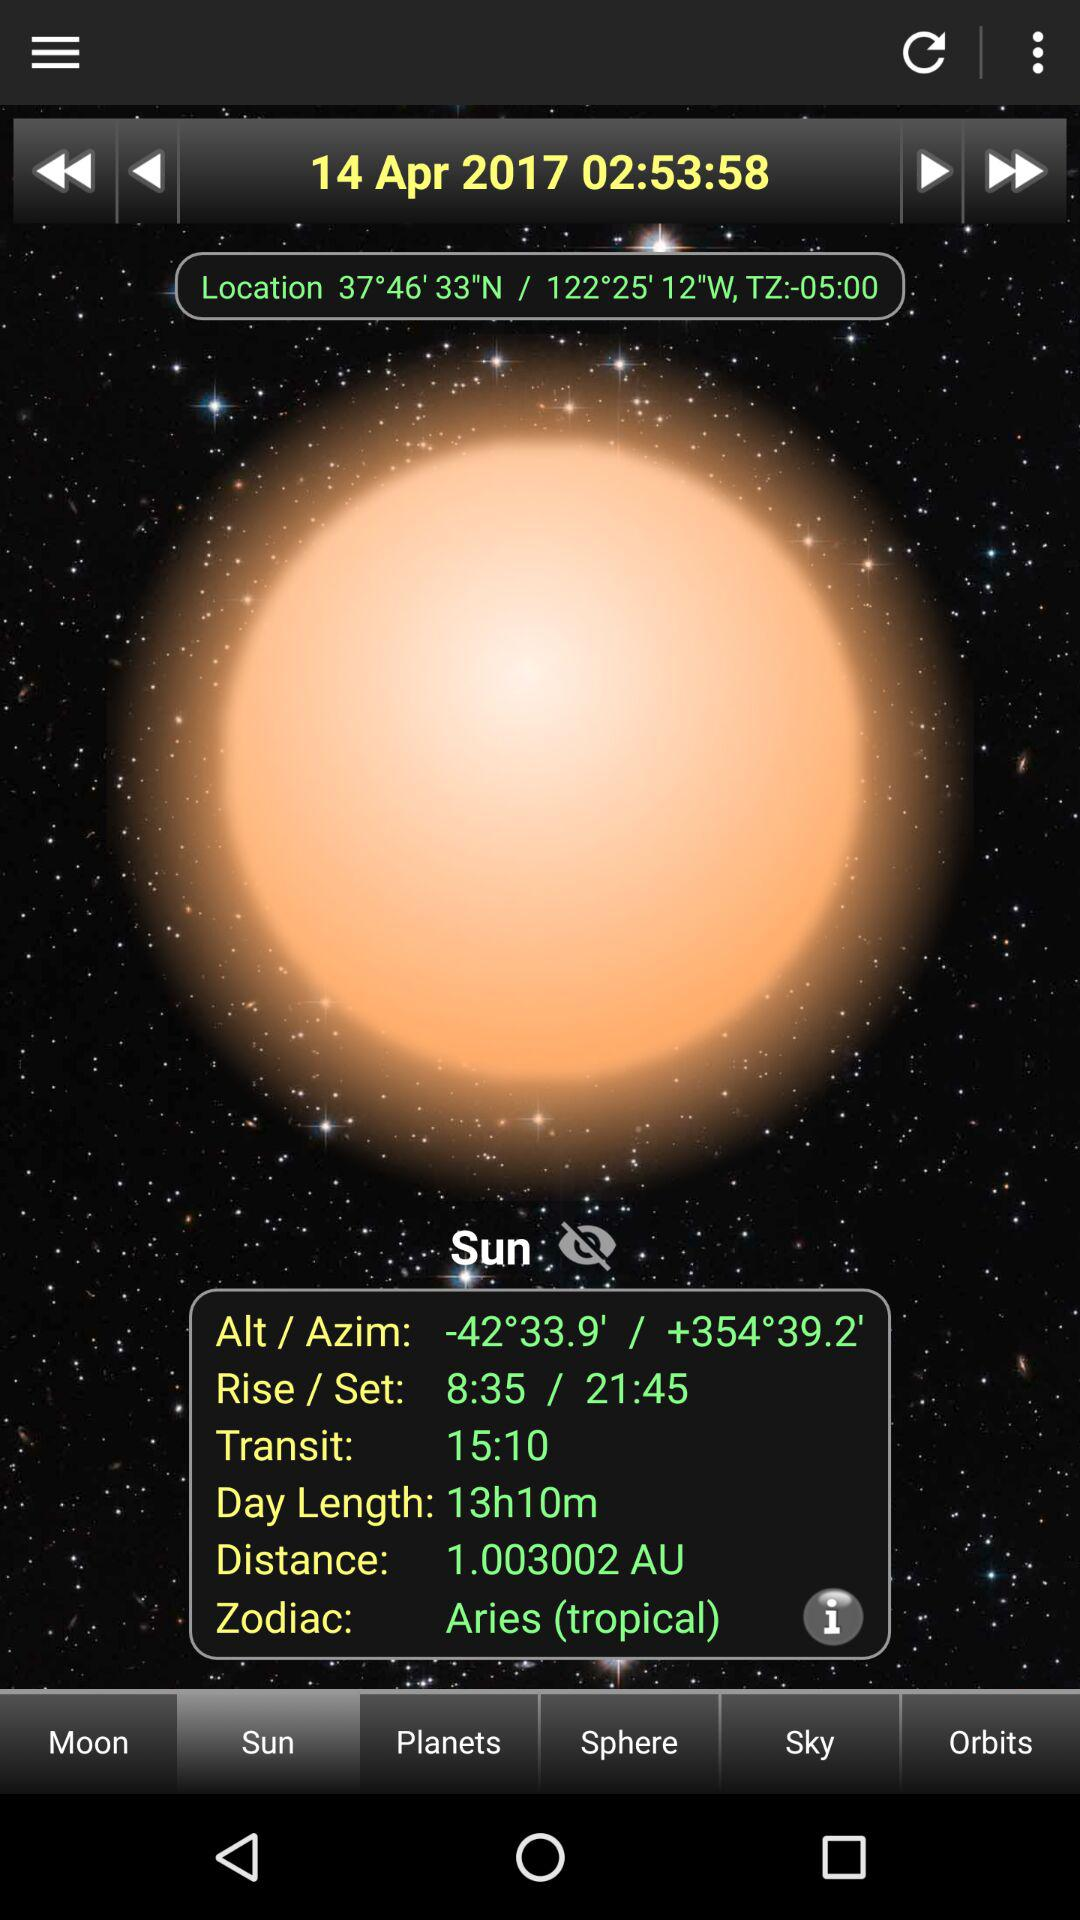How much time is there between the Sun's rise and set?
Answer the question using a single word or phrase. 13h10m 